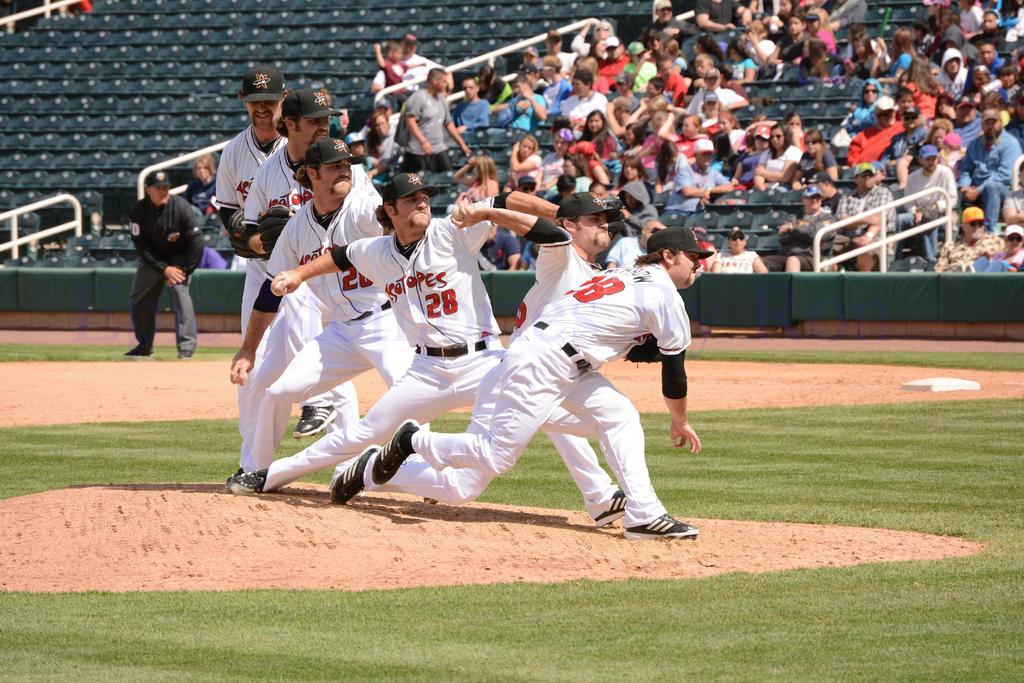Provide a one-sentence caption for the provided image. Player number 28 winds up and pitches the baseball. 